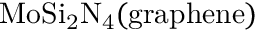Convert formula to latex. <formula><loc_0><loc_0><loc_500><loc_500>M o S i _ { 2 } N _ { 4 } ( g r a p h e n e )</formula> 